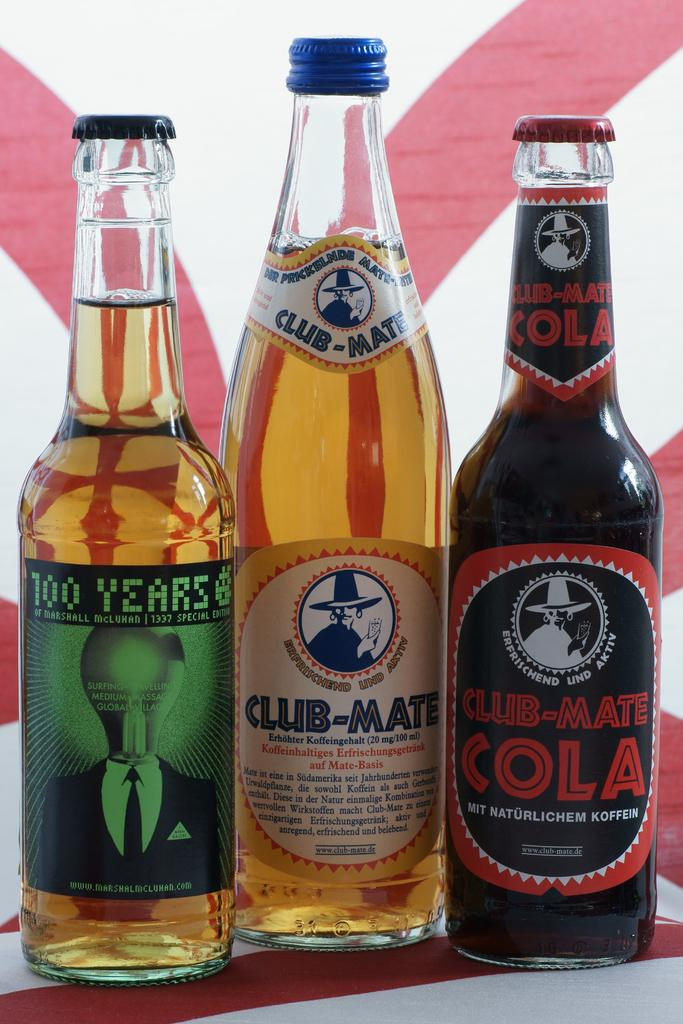<image>
Describe the image concisely. three bottles of drinks like Club-Mate on a red and white surface 